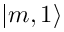Convert formula to latex. <formula><loc_0><loc_0><loc_500><loc_500>| m , 1 \rangle</formula> 